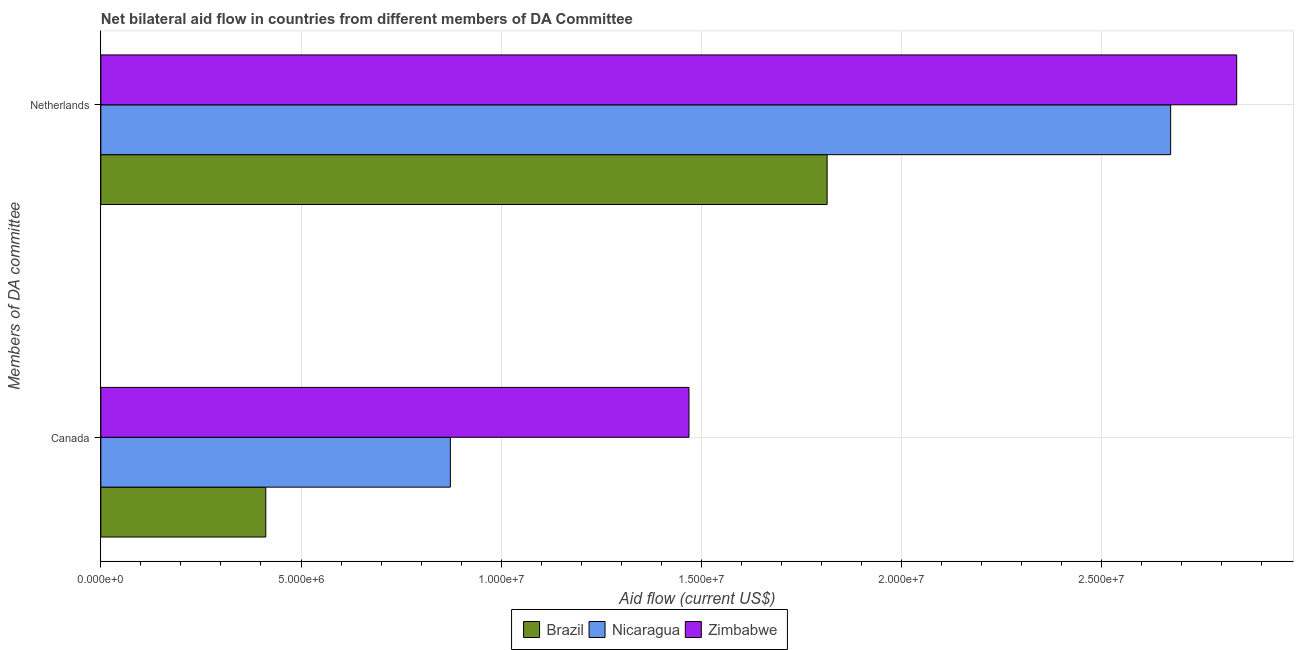Are the number of bars per tick equal to the number of legend labels?
Your response must be concise. Yes. Are the number of bars on each tick of the Y-axis equal?
Keep it short and to the point. Yes. How many bars are there on the 1st tick from the top?
Ensure brevity in your answer.  3. What is the label of the 1st group of bars from the top?
Offer a terse response. Netherlands. What is the amount of aid given by canada in Zimbabwe?
Make the answer very short. 1.47e+07. Across all countries, what is the maximum amount of aid given by canada?
Your answer should be compact. 1.47e+07. Across all countries, what is the minimum amount of aid given by netherlands?
Make the answer very short. 1.81e+07. In which country was the amount of aid given by canada maximum?
Keep it short and to the point. Zimbabwe. In which country was the amount of aid given by netherlands minimum?
Offer a terse response. Brazil. What is the total amount of aid given by canada in the graph?
Provide a short and direct response. 2.75e+07. What is the difference between the amount of aid given by canada in Nicaragua and that in Brazil?
Ensure brevity in your answer.  4.61e+06. What is the difference between the amount of aid given by netherlands in Zimbabwe and the amount of aid given by canada in Brazil?
Your answer should be compact. 2.42e+07. What is the average amount of aid given by canada per country?
Ensure brevity in your answer.  9.18e+06. What is the difference between the amount of aid given by canada and amount of aid given by netherlands in Zimbabwe?
Your answer should be very brief. -1.37e+07. What is the ratio of the amount of aid given by netherlands in Nicaragua to that in Zimbabwe?
Keep it short and to the point. 0.94. Are all the bars in the graph horizontal?
Your answer should be very brief. Yes. What is the difference between two consecutive major ticks on the X-axis?
Offer a very short reply. 5.00e+06. Are the values on the major ticks of X-axis written in scientific E-notation?
Offer a very short reply. Yes. What is the title of the graph?
Make the answer very short. Net bilateral aid flow in countries from different members of DA Committee. Does "Belize" appear as one of the legend labels in the graph?
Offer a terse response. No. What is the label or title of the X-axis?
Offer a very short reply. Aid flow (current US$). What is the label or title of the Y-axis?
Provide a succinct answer. Members of DA committee. What is the Aid flow (current US$) in Brazil in Canada?
Make the answer very short. 4.12e+06. What is the Aid flow (current US$) of Nicaragua in Canada?
Give a very brief answer. 8.73e+06. What is the Aid flow (current US$) of Zimbabwe in Canada?
Make the answer very short. 1.47e+07. What is the Aid flow (current US$) of Brazil in Netherlands?
Offer a terse response. 1.81e+07. What is the Aid flow (current US$) of Nicaragua in Netherlands?
Your answer should be very brief. 2.67e+07. What is the Aid flow (current US$) of Zimbabwe in Netherlands?
Ensure brevity in your answer.  2.84e+07. Across all Members of DA committee, what is the maximum Aid flow (current US$) of Brazil?
Give a very brief answer. 1.81e+07. Across all Members of DA committee, what is the maximum Aid flow (current US$) of Nicaragua?
Provide a short and direct response. 2.67e+07. Across all Members of DA committee, what is the maximum Aid flow (current US$) of Zimbabwe?
Keep it short and to the point. 2.84e+07. Across all Members of DA committee, what is the minimum Aid flow (current US$) in Brazil?
Your answer should be compact. 4.12e+06. Across all Members of DA committee, what is the minimum Aid flow (current US$) of Nicaragua?
Your response must be concise. 8.73e+06. Across all Members of DA committee, what is the minimum Aid flow (current US$) in Zimbabwe?
Offer a terse response. 1.47e+07. What is the total Aid flow (current US$) in Brazil in the graph?
Keep it short and to the point. 2.23e+07. What is the total Aid flow (current US$) in Nicaragua in the graph?
Offer a terse response. 3.54e+07. What is the total Aid flow (current US$) in Zimbabwe in the graph?
Offer a very short reply. 4.31e+07. What is the difference between the Aid flow (current US$) of Brazil in Canada and that in Netherlands?
Give a very brief answer. -1.40e+07. What is the difference between the Aid flow (current US$) of Nicaragua in Canada and that in Netherlands?
Your answer should be compact. -1.80e+07. What is the difference between the Aid flow (current US$) in Zimbabwe in Canada and that in Netherlands?
Keep it short and to the point. -1.37e+07. What is the difference between the Aid flow (current US$) in Brazil in Canada and the Aid flow (current US$) in Nicaragua in Netherlands?
Make the answer very short. -2.26e+07. What is the difference between the Aid flow (current US$) of Brazil in Canada and the Aid flow (current US$) of Zimbabwe in Netherlands?
Keep it short and to the point. -2.42e+07. What is the difference between the Aid flow (current US$) in Nicaragua in Canada and the Aid flow (current US$) in Zimbabwe in Netherlands?
Your answer should be very brief. -1.96e+07. What is the average Aid flow (current US$) in Brazil per Members of DA committee?
Offer a very short reply. 1.11e+07. What is the average Aid flow (current US$) of Nicaragua per Members of DA committee?
Make the answer very short. 1.77e+07. What is the average Aid flow (current US$) in Zimbabwe per Members of DA committee?
Make the answer very short. 2.15e+07. What is the difference between the Aid flow (current US$) in Brazil and Aid flow (current US$) in Nicaragua in Canada?
Your answer should be compact. -4.61e+06. What is the difference between the Aid flow (current US$) in Brazil and Aid flow (current US$) in Zimbabwe in Canada?
Offer a very short reply. -1.06e+07. What is the difference between the Aid flow (current US$) of Nicaragua and Aid flow (current US$) of Zimbabwe in Canada?
Give a very brief answer. -5.96e+06. What is the difference between the Aid flow (current US$) in Brazil and Aid flow (current US$) in Nicaragua in Netherlands?
Keep it short and to the point. -8.58e+06. What is the difference between the Aid flow (current US$) of Brazil and Aid flow (current US$) of Zimbabwe in Netherlands?
Provide a short and direct response. -1.02e+07. What is the difference between the Aid flow (current US$) in Nicaragua and Aid flow (current US$) in Zimbabwe in Netherlands?
Provide a short and direct response. -1.65e+06. What is the ratio of the Aid flow (current US$) of Brazil in Canada to that in Netherlands?
Ensure brevity in your answer.  0.23. What is the ratio of the Aid flow (current US$) in Nicaragua in Canada to that in Netherlands?
Provide a short and direct response. 0.33. What is the ratio of the Aid flow (current US$) in Zimbabwe in Canada to that in Netherlands?
Ensure brevity in your answer.  0.52. What is the difference between the highest and the second highest Aid flow (current US$) in Brazil?
Make the answer very short. 1.40e+07. What is the difference between the highest and the second highest Aid flow (current US$) in Nicaragua?
Provide a short and direct response. 1.80e+07. What is the difference between the highest and the second highest Aid flow (current US$) of Zimbabwe?
Your answer should be very brief. 1.37e+07. What is the difference between the highest and the lowest Aid flow (current US$) in Brazil?
Your answer should be compact. 1.40e+07. What is the difference between the highest and the lowest Aid flow (current US$) of Nicaragua?
Offer a terse response. 1.80e+07. What is the difference between the highest and the lowest Aid flow (current US$) of Zimbabwe?
Offer a terse response. 1.37e+07. 